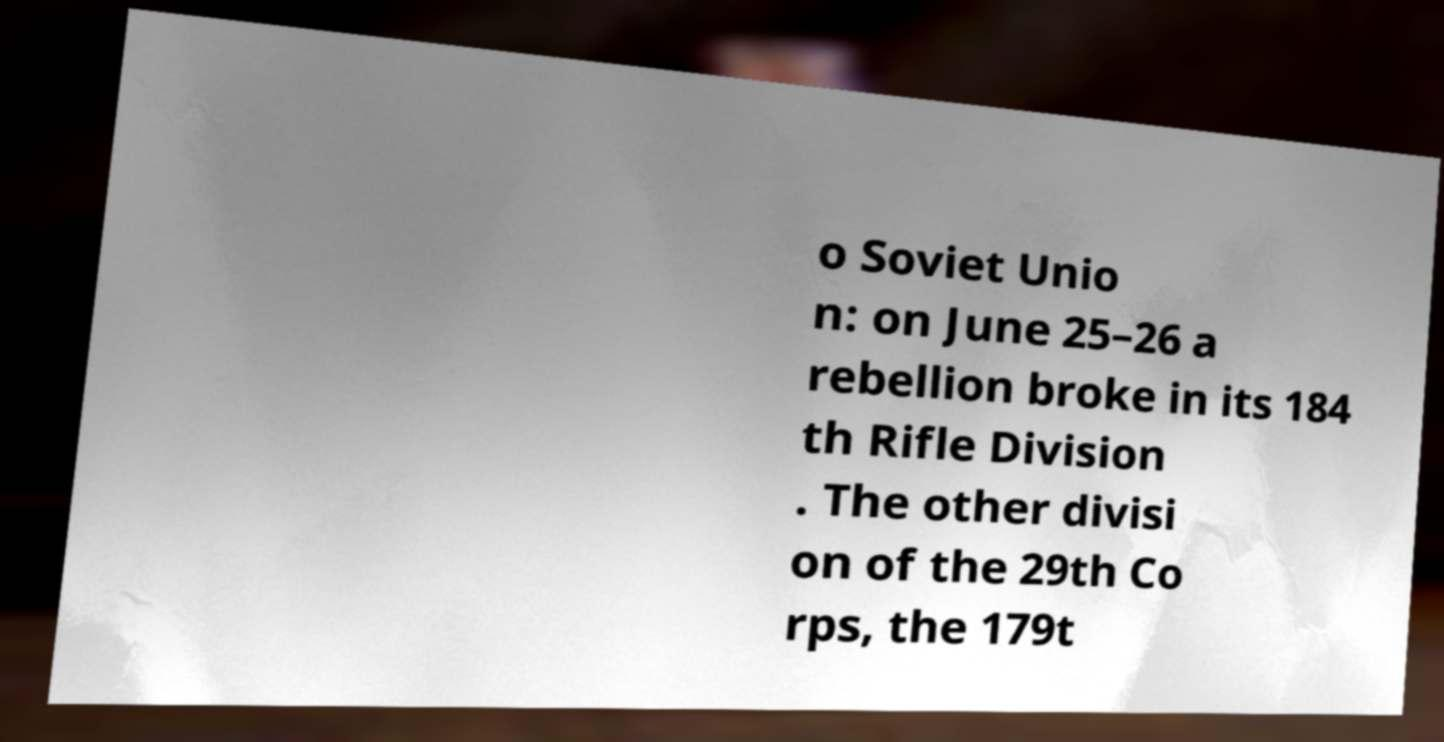Please read and relay the text visible in this image. What does it say? o Soviet Unio n: on June 25–26 a rebellion broke in its 184 th Rifle Division . The other divisi on of the 29th Co rps, the 179t 